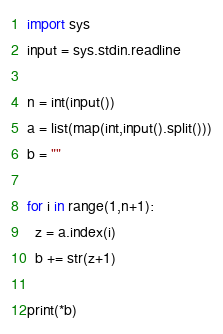Convert code to text. <code><loc_0><loc_0><loc_500><loc_500><_Python_>import sys
input = sys.stdin.readline

n = int(input())
a = list(map(int,input().split()))
b = ""

for i in range(1,n+1):
  z = a.index(i)
  b += str(z+1)
  
print(*b)
</code> 